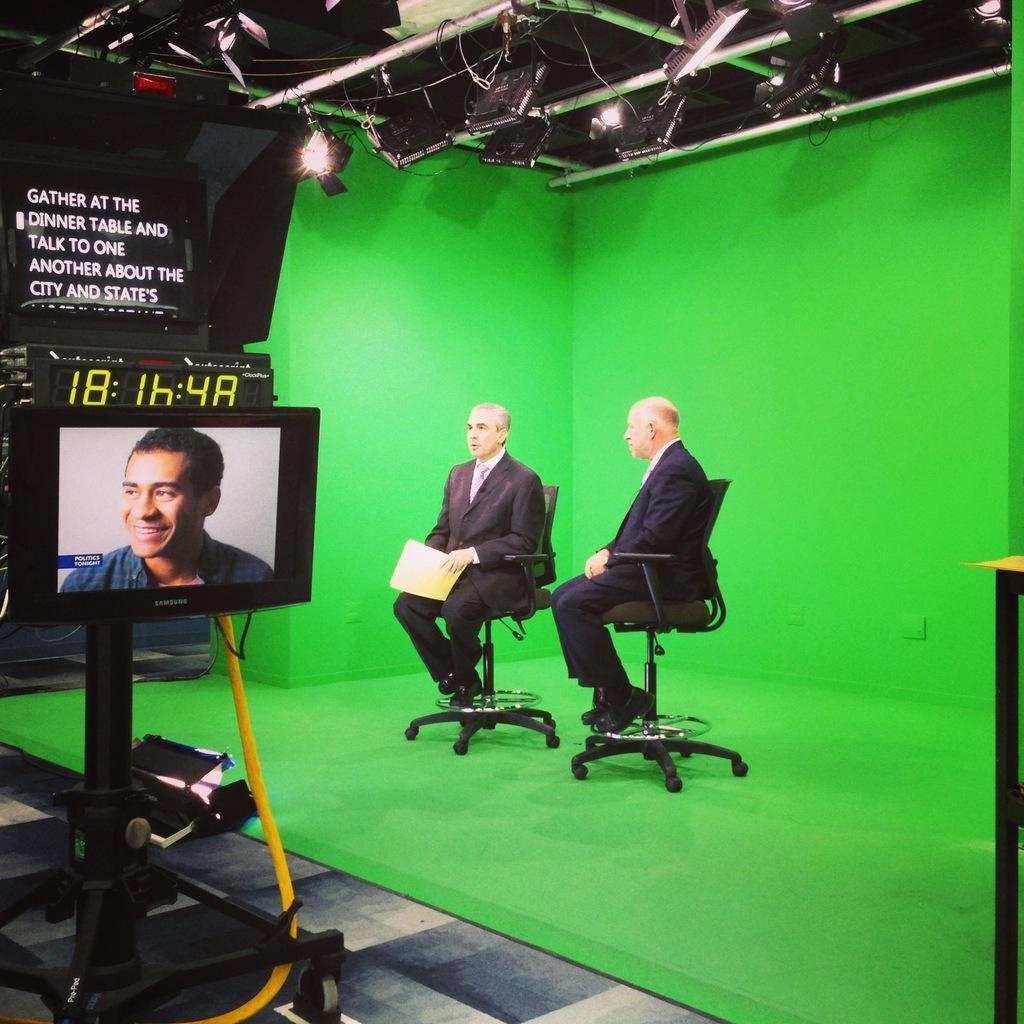Please provide a concise description of this image. In this picture we can see two men wearing a black suit sitting on the chairs for the media interview. Behind we can see a green background. On the left bottom side we can see a television screen. 